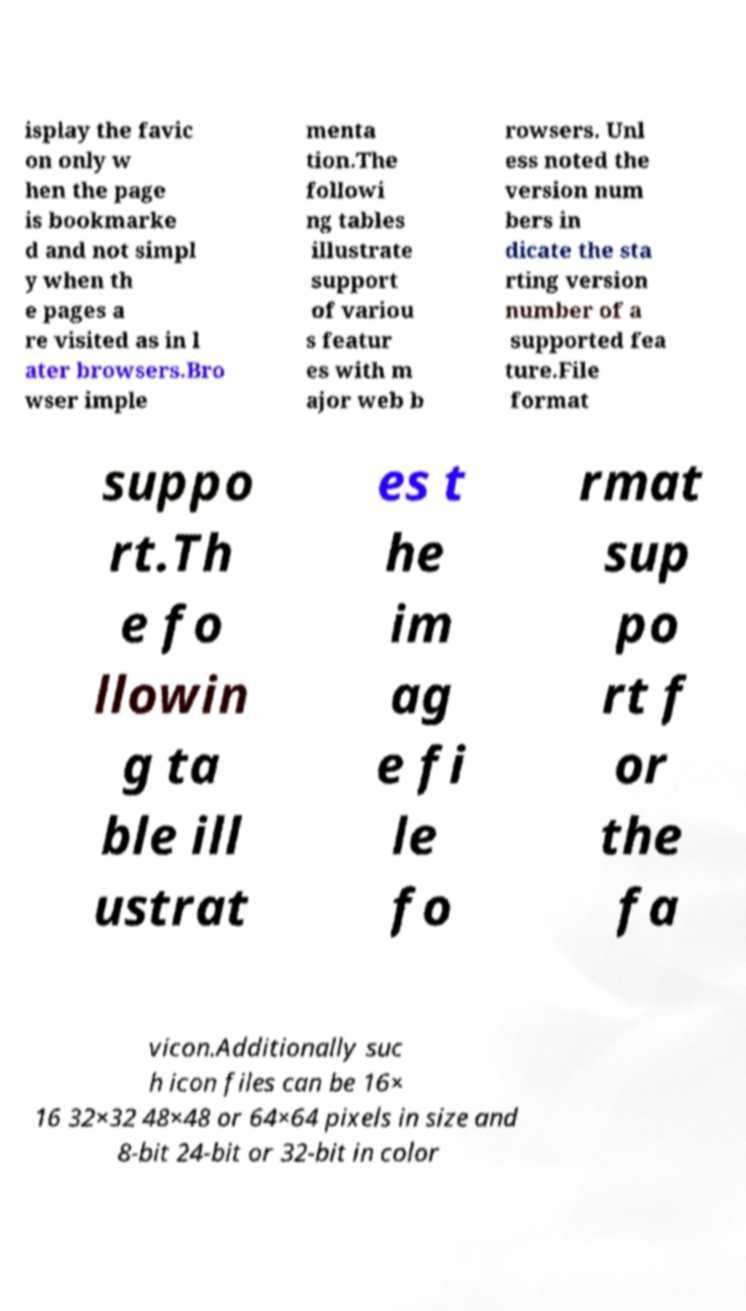For documentation purposes, I need the text within this image transcribed. Could you provide that? isplay the favic on only w hen the page is bookmarke d and not simpl y when th e pages a re visited as in l ater browsers.Bro wser imple menta tion.The followi ng tables illustrate support of variou s featur es with m ajor web b rowsers. Unl ess noted the version num bers in dicate the sta rting version number of a supported fea ture.File format suppo rt.Th e fo llowin g ta ble ill ustrat es t he im ag e fi le fo rmat sup po rt f or the fa vicon.Additionally suc h icon files can be 16× 16 32×32 48×48 or 64×64 pixels in size and 8-bit 24-bit or 32-bit in color 